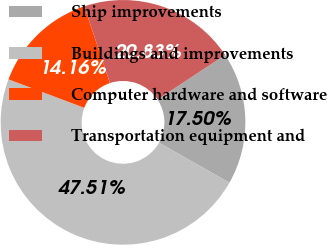Convert chart to OTSL. <chart><loc_0><loc_0><loc_500><loc_500><pie_chart><fcel>Ship improvements<fcel>Buildings and improvements<fcel>Computer hardware and software<fcel>Transportation equipment and<nl><fcel>17.5%<fcel>47.51%<fcel>14.16%<fcel>20.83%<nl></chart> 